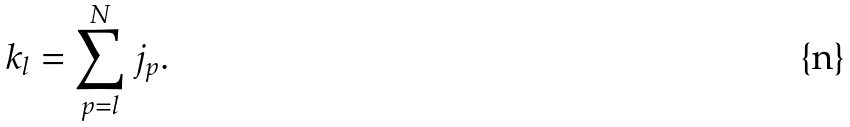Convert formula to latex. <formula><loc_0><loc_0><loc_500><loc_500>k _ { l } = \sum _ { p = l } ^ { N } j _ { p } .</formula> 